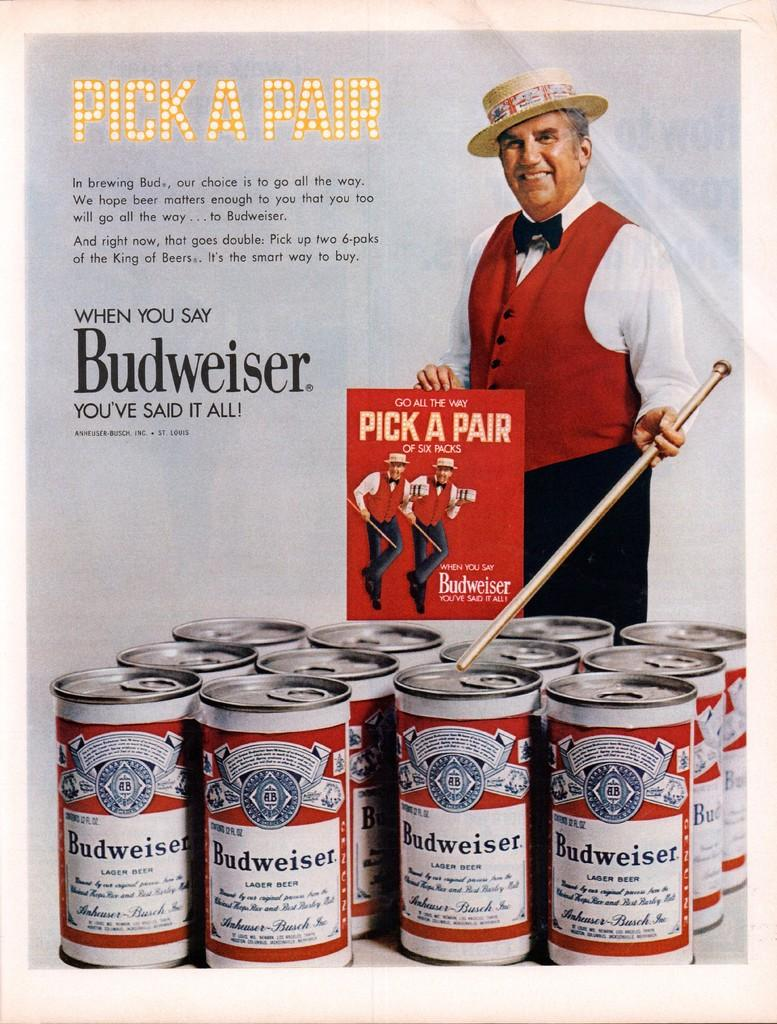What is the main object in the image? There is a poster in the image. What is depicted on the poster? The poster has cans and a person's image holding a stick. Are there any words on the poster? Yes, there is text written on the poster. How many parcels are being delivered by the person in the poster? There are no parcels depicted in the image; the person is holding a stick. What type of steel is used to make the cans in the poster? There is no information about the type of steel used to make the cans in the image. 